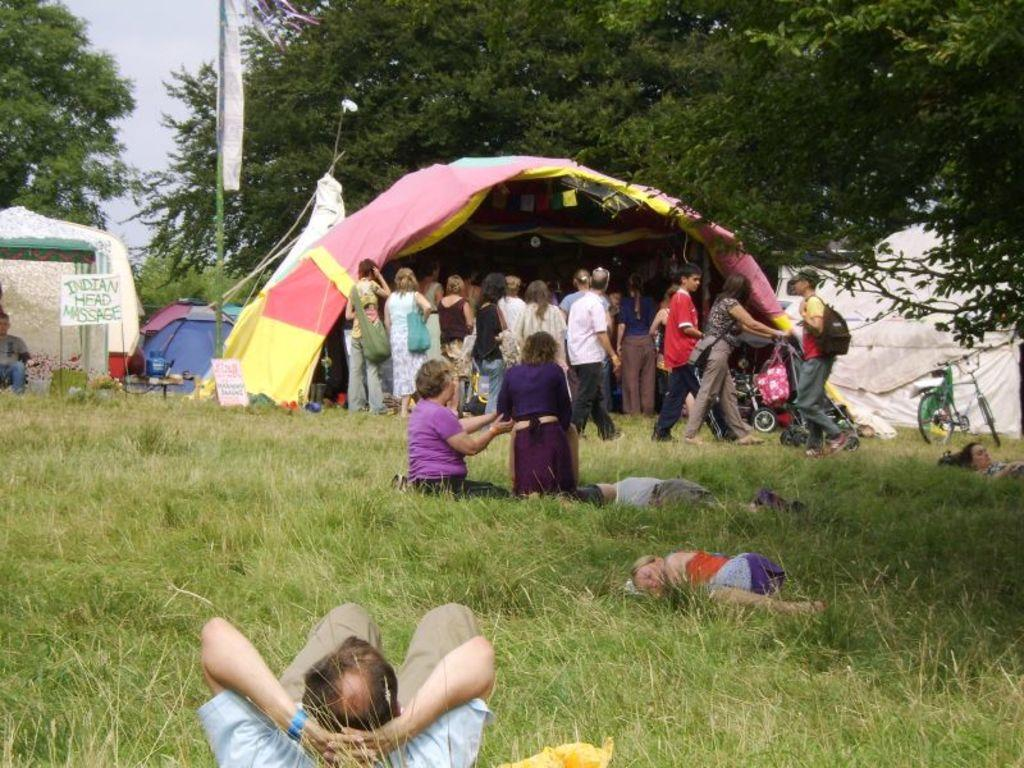How many people are in the image? There are people in the image, but the exact number is not specified. What type of terrain is visible in the image? There is grass in the image, which suggests a grassy or park-like setting. What type of vehicle is in the image? There is a bicycle in the image. What structure is present in the image? There is a pole in the image. What type of signage is in the image? There are boards and a banner in the image. What type of temporary shelter is in the image? There are tents in the image. What type of natural elements are in the image? There are trees in the image. What part of the natural environment is visible in the image? The sky is visible in the image. What type of lipstick is being advertised on the banner in the image? There is no lipstick or any advertisement mentioned in the image. How does the low-hanging branch affect the visibility of the tents in the image? There is no mention of a low-hanging branch in the image, so its effect on the visibility of the tents cannot be determined. 